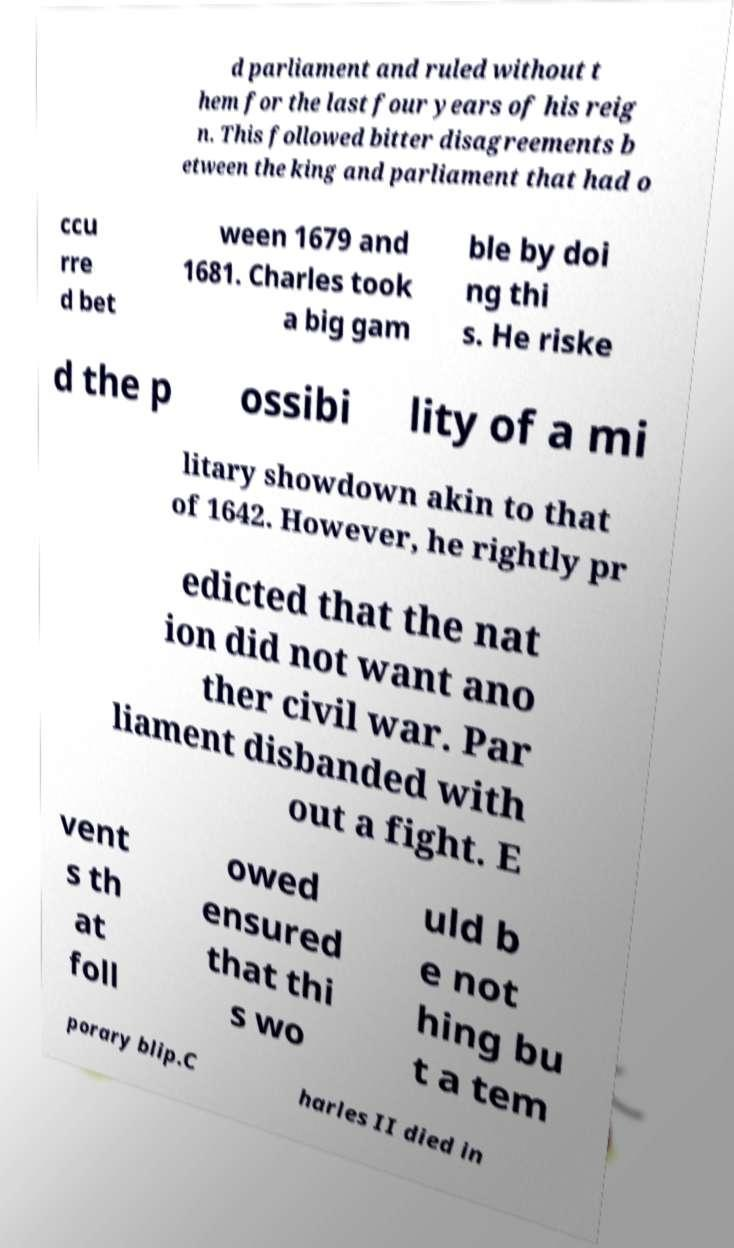There's text embedded in this image that I need extracted. Can you transcribe it verbatim? d parliament and ruled without t hem for the last four years of his reig n. This followed bitter disagreements b etween the king and parliament that had o ccu rre d bet ween 1679 and 1681. Charles took a big gam ble by doi ng thi s. He riske d the p ossibi lity of a mi litary showdown akin to that of 1642. However, he rightly pr edicted that the nat ion did not want ano ther civil war. Par liament disbanded with out a fight. E vent s th at foll owed ensured that thi s wo uld b e not hing bu t a tem porary blip.C harles II died in 